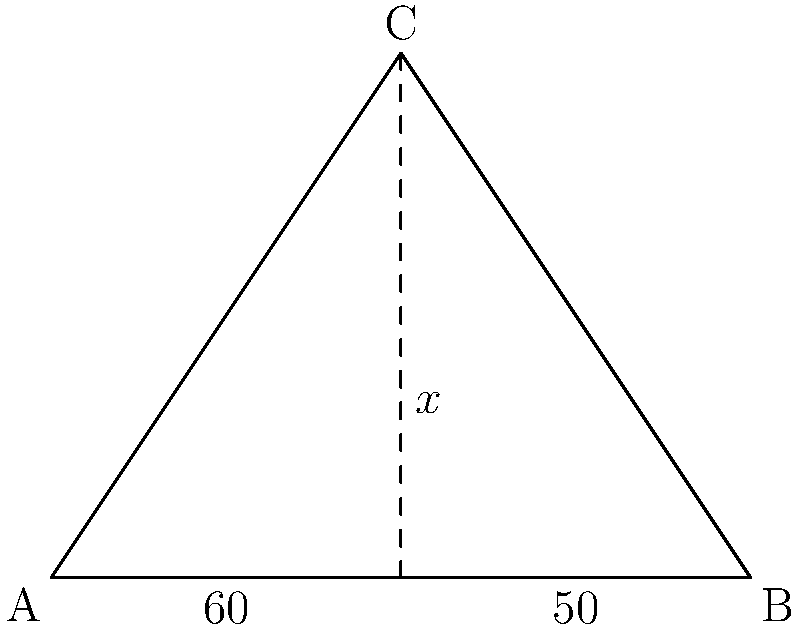In a museum display, three rare surgical instruments are arranged to form a triangle ABC. The instrument from A to C forms an angle of 60° with the base AB, while the instrument from B to C forms an angle of 50° with AB. What is the measure of angle ACB, denoted as $x°$ in the diagram? Let's solve this step-by-step:

1) In any triangle, the sum of all interior angles is always 180°.

2) We can see that the triangle is divided into three smaller triangles by the dashed lines.

3) The base angles of these smaller triangles are given: 60° and 50°.

4) Let's call the angle at the top of each of these smaller triangles $y°$ and $z°$ respectively.

5) For the left smaller triangle:
   $60° + y° + 90° = 180°$ (sum of angles in a triangle)
   $y° = 30°$

6) For the right smaller triangle:
   $50° + z° + 90° = 180°$
   $z° = 40°$

7) Now, the angle we're looking for, $x°$, is the sum of these two angles:
   $x° = y° + z° = 30° + 40° = 70°$

Therefore, the measure of angle ACB is 70°.
Answer: 70° 